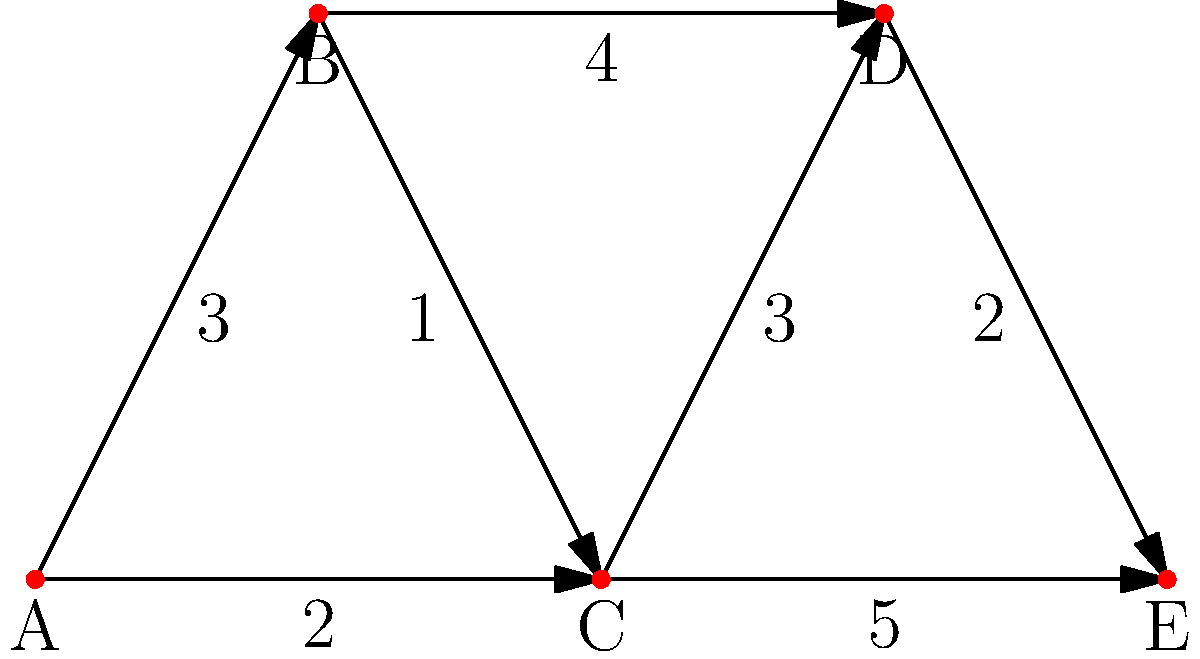As a military leader optimizing supply routes, you're presented with a network of strategic locations. The diagram shows the connections between locations A, B, C, D, and E, with the numbers representing the cost (in hours) to traverse each route. What is the minimum total cost to establish a supply line from location A to location E? To find the minimum total cost from A to E, we'll use Dijkstra's algorithm:

1) Initialize:
   - Set A's cost to 0, all others to infinity.
   - Unvisited set: {A, B, C, D, E}

2) From A:
   - Cost to B = 3
   - Cost to C = 2
   - Mark A as visited
   - Unvisited set: {B, C, D, E}

3) Choose C (lowest cost among unvisited):
   - Cost to D = 2 + 3 = 5
   - Cost to E = 2 + 5 = 7
   - Mark C as visited
   - Unvisited set: {B, D, E}

4) Choose B (cost 3):
   - Cost to D = 3 + 4 = 7 > current cost to D (5), so no update
   - Mark B as visited
   - Unvisited set: {D, E}

5) Choose D (cost 5):
   - Cost to E = 5 + 2 = 7
   - Mark D as visited
   - Unvisited set: {E}

6) Choose E (cost 7):
   - Mark E as visited
   - Algorithm complete

The minimum cost path from A to E is 7 hours, likely following the route A → C → D → E.
Answer: 7 hours 